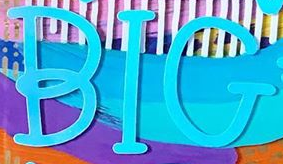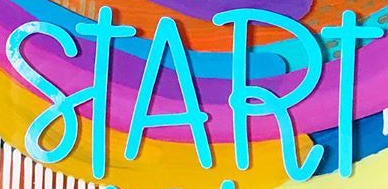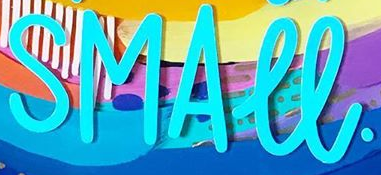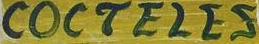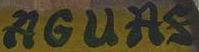Read the text from these images in sequence, separated by a semicolon. BIG; START; SMALL.; COCTELES; AGUAS 